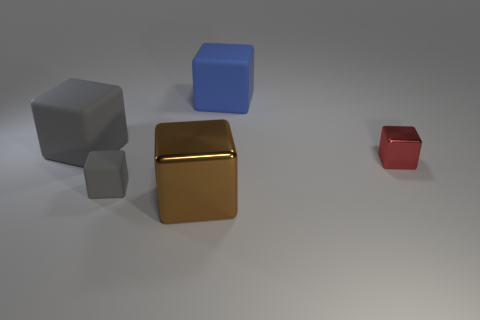Is the color of the block that is to the left of the tiny gray block the same as the tiny matte object?
Your answer should be compact. Yes. Do the big matte thing to the left of the blue rubber object and the tiny cube that is in front of the small red shiny object have the same color?
Give a very brief answer. Yes. What is the shape of the rubber object that is the same color as the small matte cube?
Offer a terse response. Cube. How many other objects are the same size as the red block?
Offer a very short reply. 1. There is a large thing in front of the gray matte block that is behind the tiny thing to the left of the small metallic block; what color is it?
Keep it short and to the point. Brown. How many other objects are there of the same shape as the small red shiny thing?
Offer a terse response. 4. What shape is the big thing that is on the right side of the brown metallic block?
Provide a succinct answer. Cube. Is there a large blue block that is on the left side of the small rubber cube on the left side of the large brown thing?
Ensure brevity in your answer.  No. The rubber object that is both behind the tiny gray rubber block and right of the big gray matte object is what color?
Your response must be concise. Blue. Is there a red cube that is in front of the big matte cube right of the rubber object on the left side of the tiny gray matte cube?
Keep it short and to the point. Yes. 